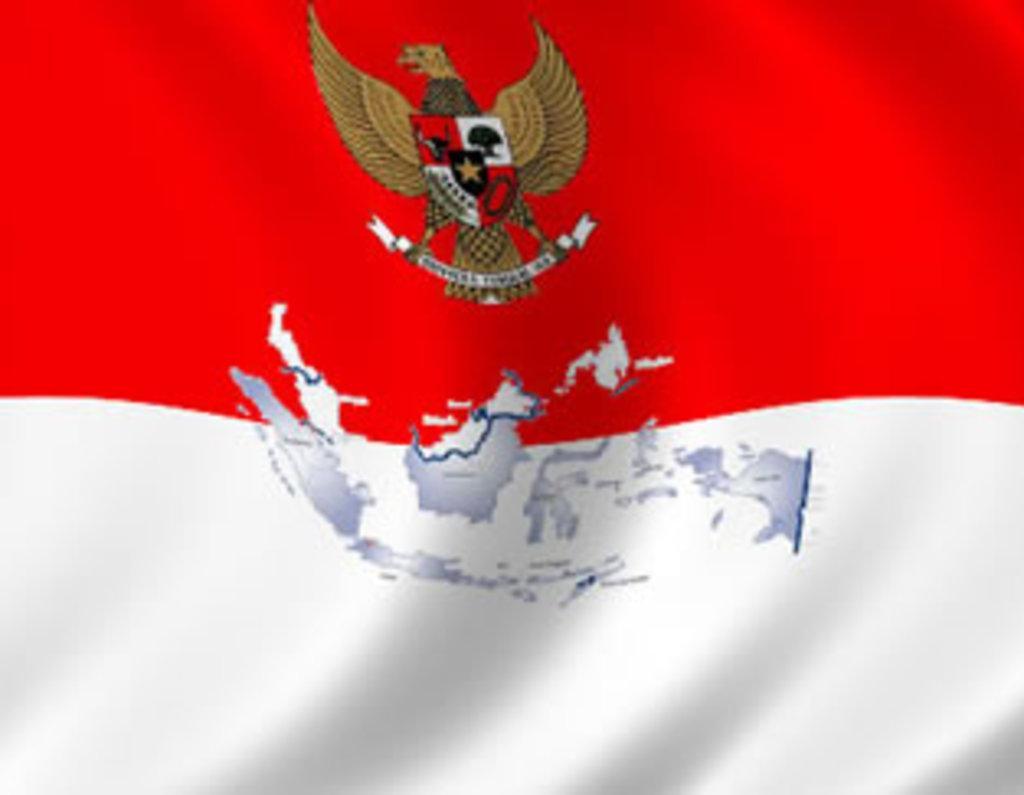Please provide a concise description of this image. This picture shows a flag and we see a map and a bird on it. It is red and white in color. 